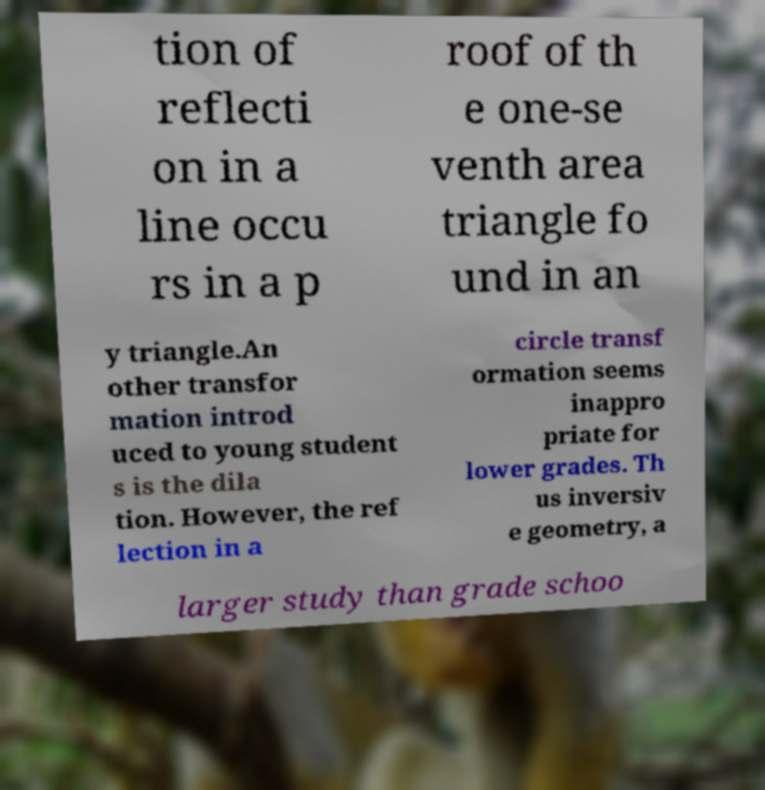There's text embedded in this image that I need extracted. Can you transcribe it verbatim? tion of reflecti on in a line occu rs in a p roof of th e one-se venth area triangle fo und in an y triangle.An other transfor mation introd uced to young student s is the dila tion. However, the ref lection in a circle transf ormation seems inappro priate for lower grades. Th us inversiv e geometry, a larger study than grade schoo 